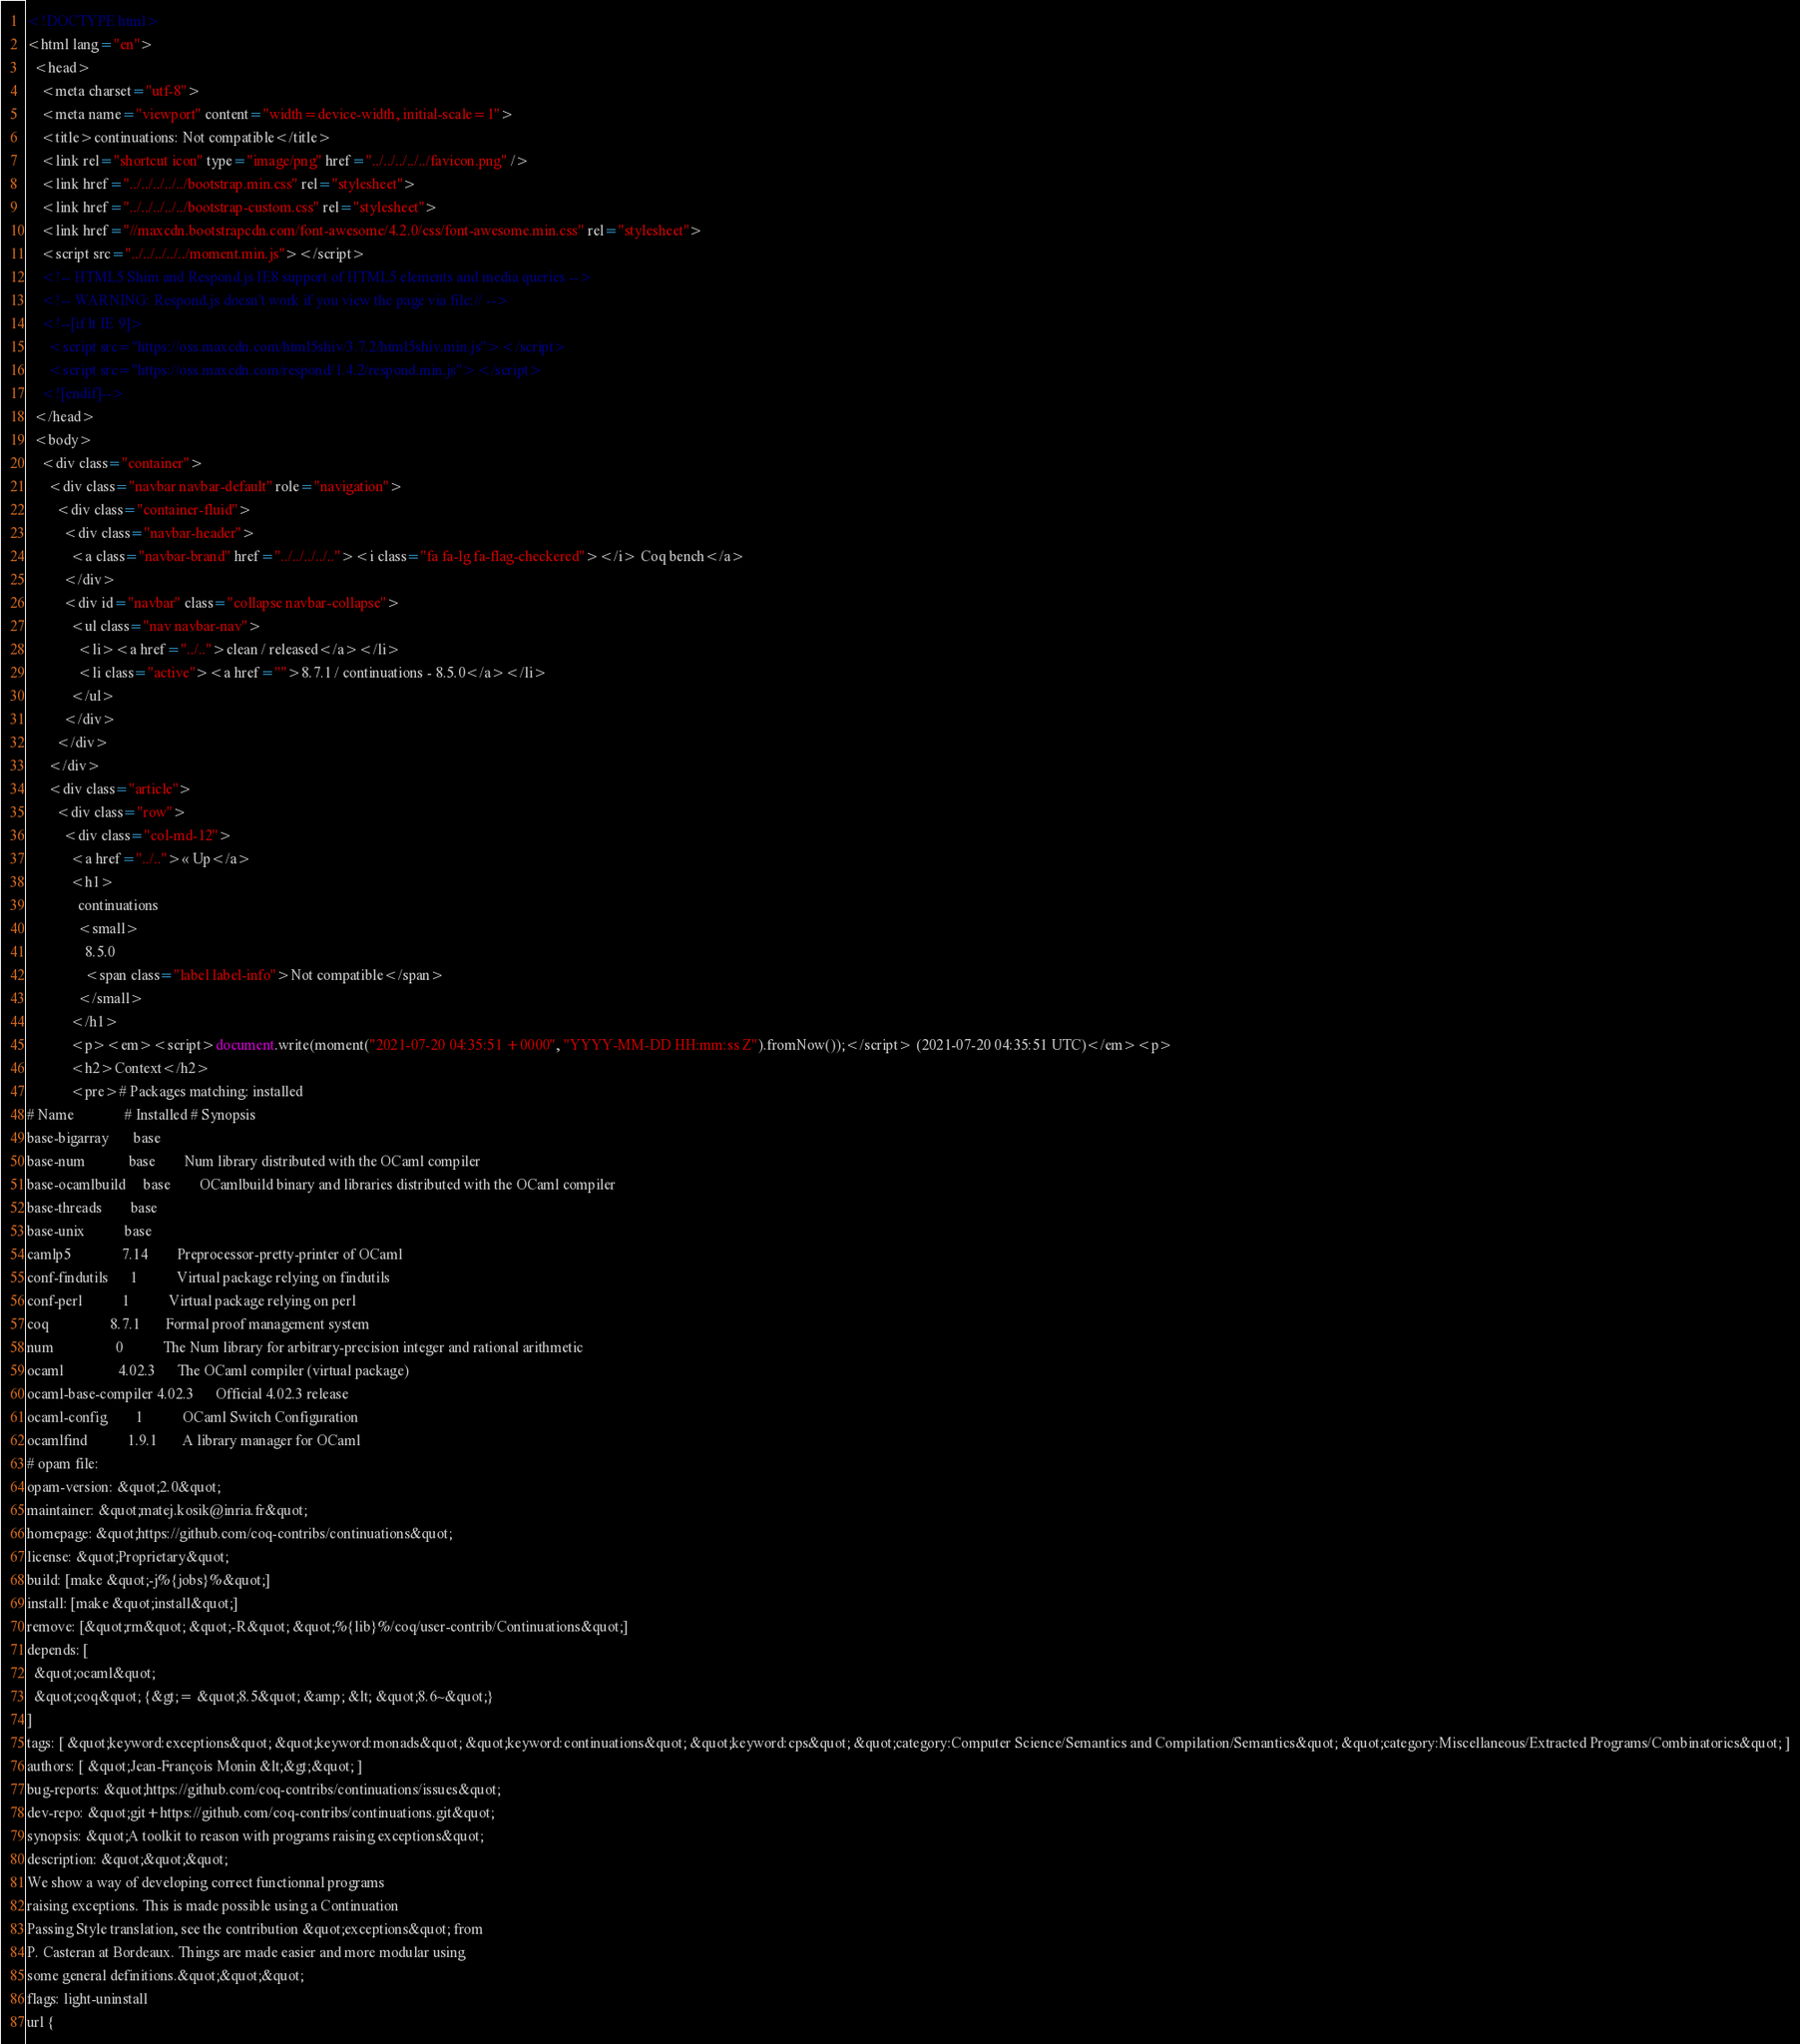<code> <loc_0><loc_0><loc_500><loc_500><_HTML_><!DOCTYPE html>
<html lang="en">
  <head>
    <meta charset="utf-8">
    <meta name="viewport" content="width=device-width, initial-scale=1">
    <title>continuations: Not compatible</title>
    <link rel="shortcut icon" type="image/png" href="../../../../../favicon.png" />
    <link href="../../../../../bootstrap.min.css" rel="stylesheet">
    <link href="../../../../../bootstrap-custom.css" rel="stylesheet">
    <link href="//maxcdn.bootstrapcdn.com/font-awesome/4.2.0/css/font-awesome.min.css" rel="stylesheet">
    <script src="../../../../../moment.min.js"></script>
    <!-- HTML5 Shim and Respond.js IE8 support of HTML5 elements and media queries -->
    <!-- WARNING: Respond.js doesn't work if you view the page via file:// -->
    <!--[if lt IE 9]>
      <script src="https://oss.maxcdn.com/html5shiv/3.7.2/html5shiv.min.js"></script>
      <script src="https://oss.maxcdn.com/respond/1.4.2/respond.min.js"></script>
    <![endif]-->
  </head>
  <body>
    <div class="container">
      <div class="navbar navbar-default" role="navigation">
        <div class="container-fluid">
          <div class="navbar-header">
            <a class="navbar-brand" href="../../../../.."><i class="fa fa-lg fa-flag-checkered"></i> Coq bench</a>
          </div>
          <div id="navbar" class="collapse navbar-collapse">
            <ul class="nav navbar-nav">
              <li><a href="../..">clean / released</a></li>
              <li class="active"><a href="">8.7.1 / continuations - 8.5.0</a></li>
            </ul>
          </div>
        </div>
      </div>
      <div class="article">
        <div class="row">
          <div class="col-md-12">
            <a href="../..">« Up</a>
            <h1>
              continuations
              <small>
                8.5.0
                <span class="label label-info">Not compatible</span>
              </small>
            </h1>
            <p><em><script>document.write(moment("2021-07-20 04:35:51 +0000", "YYYY-MM-DD HH:mm:ss Z").fromNow());</script> (2021-07-20 04:35:51 UTC)</em><p>
            <h2>Context</h2>
            <pre># Packages matching: installed
# Name              # Installed # Synopsis
base-bigarray       base
base-num            base        Num library distributed with the OCaml compiler
base-ocamlbuild     base        OCamlbuild binary and libraries distributed with the OCaml compiler
base-threads        base
base-unix           base
camlp5              7.14        Preprocessor-pretty-printer of OCaml
conf-findutils      1           Virtual package relying on findutils
conf-perl           1           Virtual package relying on perl
coq                 8.7.1       Formal proof management system
num                 0           The Num library for arbitrary-precision integer and rational arithmetic
ocaml               4.02.3      The OCaml compiler (virtual package)
ocaml-base-compiler 4.02.3      Official 4.02.3 release
ocaml-config        1           OCaml Switch Configuration
ocamlfind           1.9.1       A library manager for OCaml
# opam file:
opam-version: &quot;2.0&quot;
maintainer: &quot;matej.kosik@inria.fr&quot;
homepage: &quot;https://github.com/coq-contribs/continuations&quot;
license: &quot;Proprietary&quot;
build: [make &quot;-j%{jobs}%&quot;]
install: [make &quot;install&quot;]
remove: [&quot;rm&quot; &quot;-R&quot; &quot;%{lib}%/coq/user-contrib/Continuations&quot;]
depends: [
  &quot;ocaml&quot;
  &quot;coq&quot; {&gt;= &quot;8.5&quot; &amp; &lt; &quot;8.6~&quot;}
]
tags: [ &quot;keyword:exceptions&quot; &quot;keyword:monads&quot; &quot;keyword:continuations&quot; &quot;keyword:cps&quot; &quot;category:Computer Science/Semantics and Compilation/Semantics&quot; &quot;category:Miscellaneous/Extracted Programs/Combinatorics&quot; ]
authors: [ &quot;Jean-François Monin &lt;&gt;&quot; ]
bug-reports: &quot;https://github.com/coq-contribs/continuations/issues&quot;
dev-repo: &quot;git+https://github.com/coq-contribs/continuations.git&quot;
synopsis: &quot;A toolkit to reason with programs raising exceptions&quot;
description: &quot;&quot;&quot;
We show a way of developing correct functionnal programs
raising exceptions. This is made possible using a Continuation
Passing Style translation, see the contribution &quot;exceptions&quot; from
P. Casteran at Bordeaux. Things are made easier and more modular using
some general definitions.&quot;&quot;&quot;
flags: light-uninstall
url {</code> 